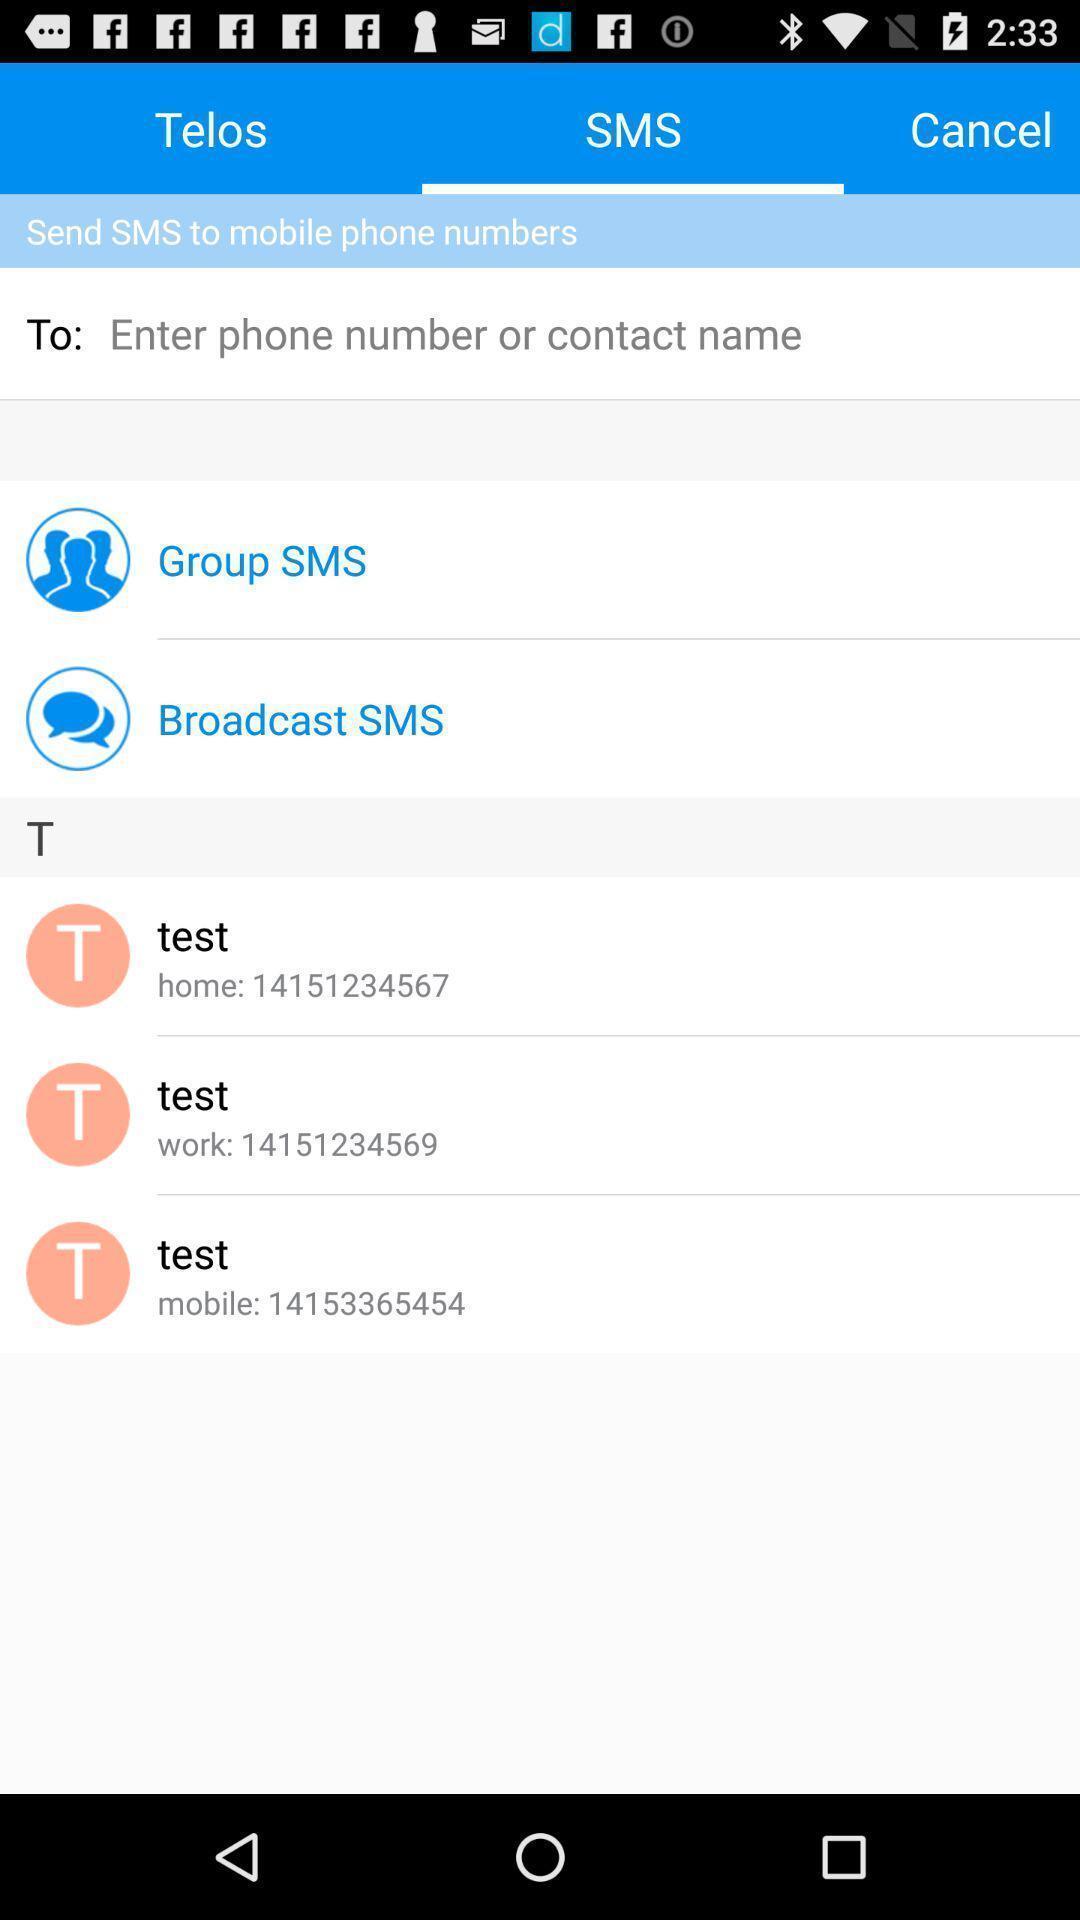What can you discern from this picture? Page for sending messages to particular mobile numbers. 